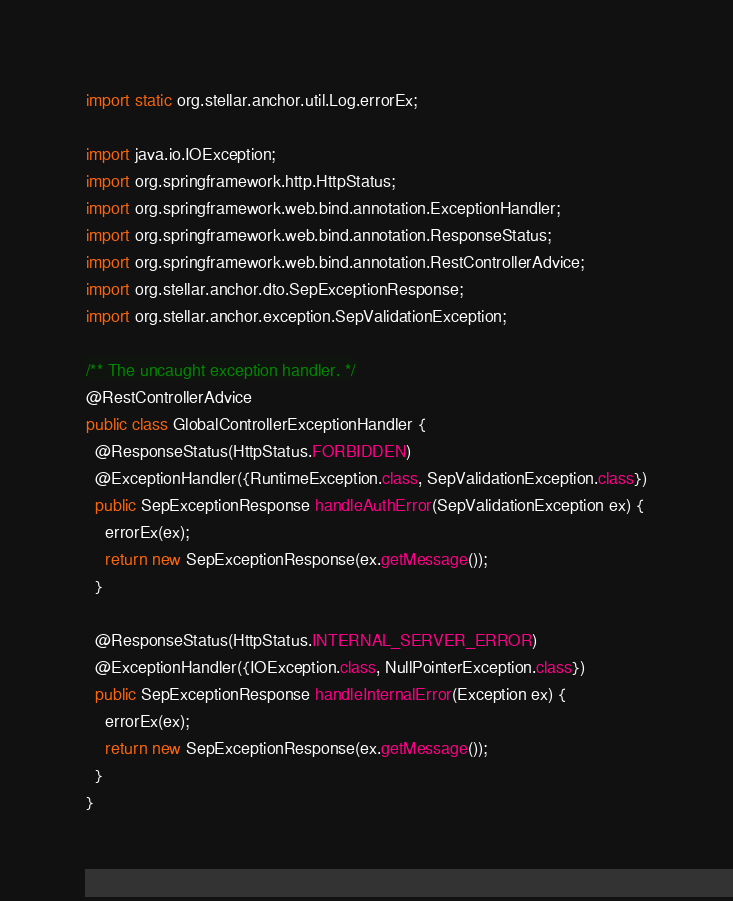Convert code to text. <code><loc_0><loc_0><loc_500><loc_500><_Java_>
import static org.stellar.anchor.util.Log.errorEx;

import java.io.IOException;
import org.springframework.http.HttpStatus;
import org.springframework.web.bind.annotation.ExceptionHandler;
import org.springframework.web.bind.annotation.ResponseStatus;
import org.springframework.web.bind.annotation.RestControllerAdvice;
import org.stellar.anchor.dto.SepExceptionResponse;
import org.stellar.anchor.exception.SepValidationException;

/** The uncaught exception handler. */
@RestControllerAdvice
public class GlobalControllerExceptionHandler {
  @ResponseStatus(HttpStatus.FORBIDDEN)
  @ExceptionHandler({RuntimeException.class, SepValidationException.class})
  public SepExceptionResponse handleAuthError(SepValidationException ex) {
    errorEx(ex);
    return new SepExceptionResponse(ex.getMessage());
  }

  @ResponseStatus(HttpStatus.INTERNAL_SERVER_ERROR)
  @ExceptionHandler({IOException.class, NullPointerException.class})
  public SepExceptionResponse handleInternalError(Exception ex) {
    errorEx(ex);
    return new SepExceptionResponse(ex.getMessage());
  }
}
</code> 